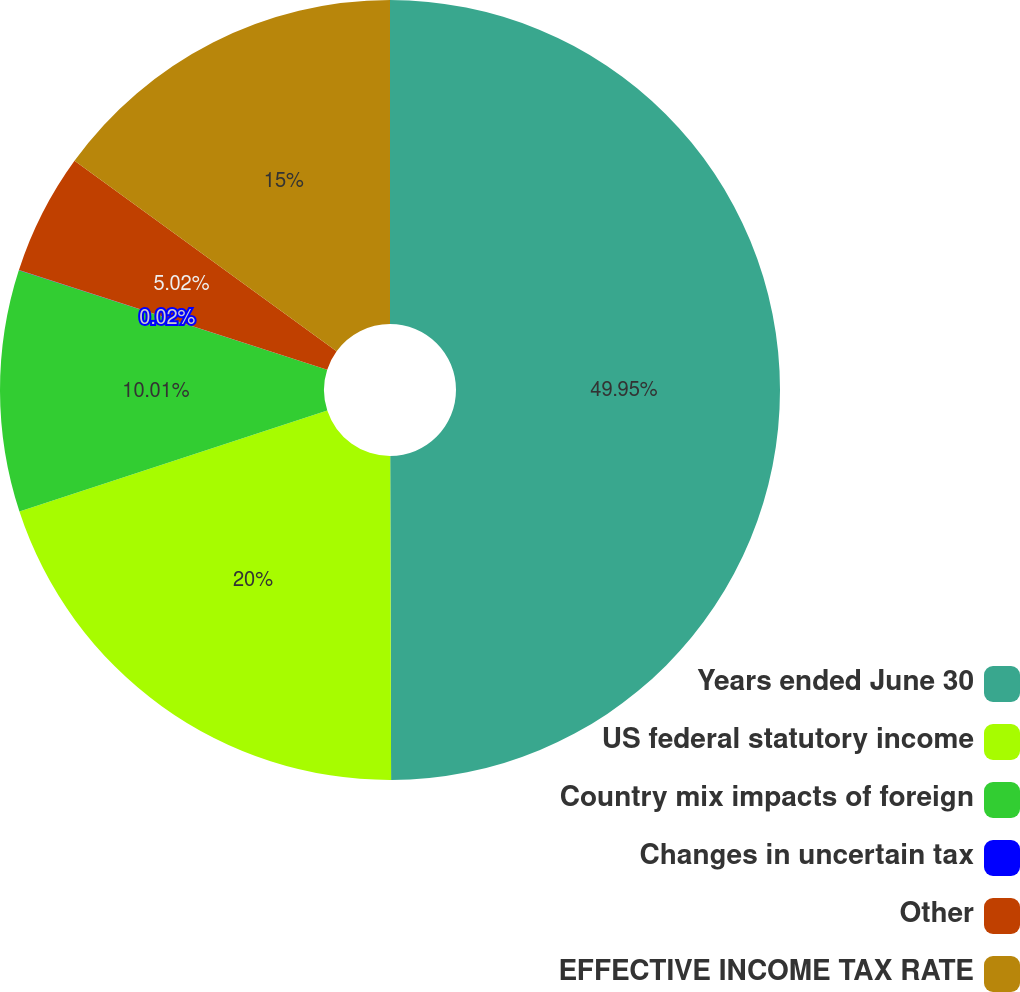Convert chart. <chart><loc_0><loc_0><loc_500><loc_500><pie_chart><fcel>Years ended June 30<fcel>US federal statutory income<fcel>Country mix impacts of foreign<fcel>Changes in uncertain tax<fcel>Other<fcel>EFFECTIVE INCOME TAX RATE<nl><fcel>49.96%<fcel>20.0%<fcel>10.01%<fcel>0.02%<fcel>5.02%<fcel>15.0%<nl></chart> 